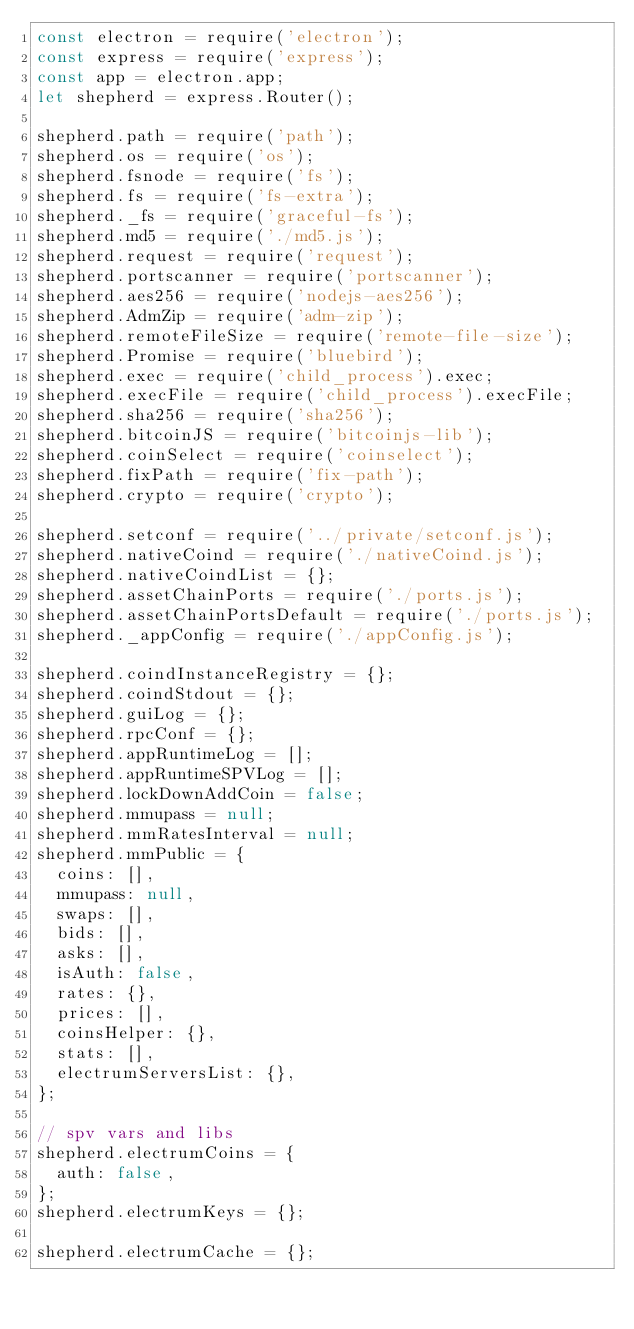Convert code to text. <code><loc_0><loc_0><loc_500><loc_500><_JavaScript_>const electron = require('electron');
const express = require('express');
const app = electron.app;
let shepherd = express.Router();

shepherd.path = require('path');
shepherd.os = require('os');
shepherd.fsnode = require('fs');
shepherd.fs = require('fs-extra');
shepherd._fs = require('graceful-fs');
shepherd.md5 = require('./md5.js');
shepherd.request = require('request');
shepherd.portscanner = require('portscanner');
shepherd.aes256 = require('nodejs-aes256');
shepherd.AdmZip = require('adm-zip');
shepherd.remoteFileSize = require('remote-file-size');
shepherd.Promise = require('bluebird');
shepherd.exec = require('child_process').exec;
shepherd.execFile = require('child_process').execFile;
shepherd.sha256 = require('sha256');
shepherd.bitcoinJS = require('bitcoinjs-lib');
shepherd.coinSelect = require('coinselect');
shepherd.fixPath = require('fix-path');
shepherd.crypto = require('crypto');

shepherd.setconf = require('../private/setconf.js');
shepherd.nativeCoind = require('./nativeCoind.js');
shepherd.nativeCoindList = {};
shepherd.assetChainPorts = require('./ports.js');
shepherd.assetChainPortsDefault = require('./ports.js');
shepherd._appConfig = require('./appConfig.js');

shepherd.coindInstanceRegistry = {};
shepherd.coindStdout = {};
shepherd.guiLog = {};
shepherd.rpcConf = {};
shepherd.appRuntimeLog = [];
shepherd.appRuntimeSPVLog = [];
shepherd.lockDownAddCoin = false;
shepherd.mmupass = null;
shepherd.mmRatesInterval = null;
shepherd.mmPublic = {
  coins: [],
  mmupass: null,
  swaps: [],
  bids: [],
  asks: [],
  isAuth: false,
  rates: {},
  prices: [],
  coinsHelper: {},
  stats: [],
  electrumServersList: {},
};

// spv vars and libs
shepherd.electrumCoins = {
  auth: false,
};
shepherd.electrumKeys = {};

shepherd.electrumCache = {};
</code> 